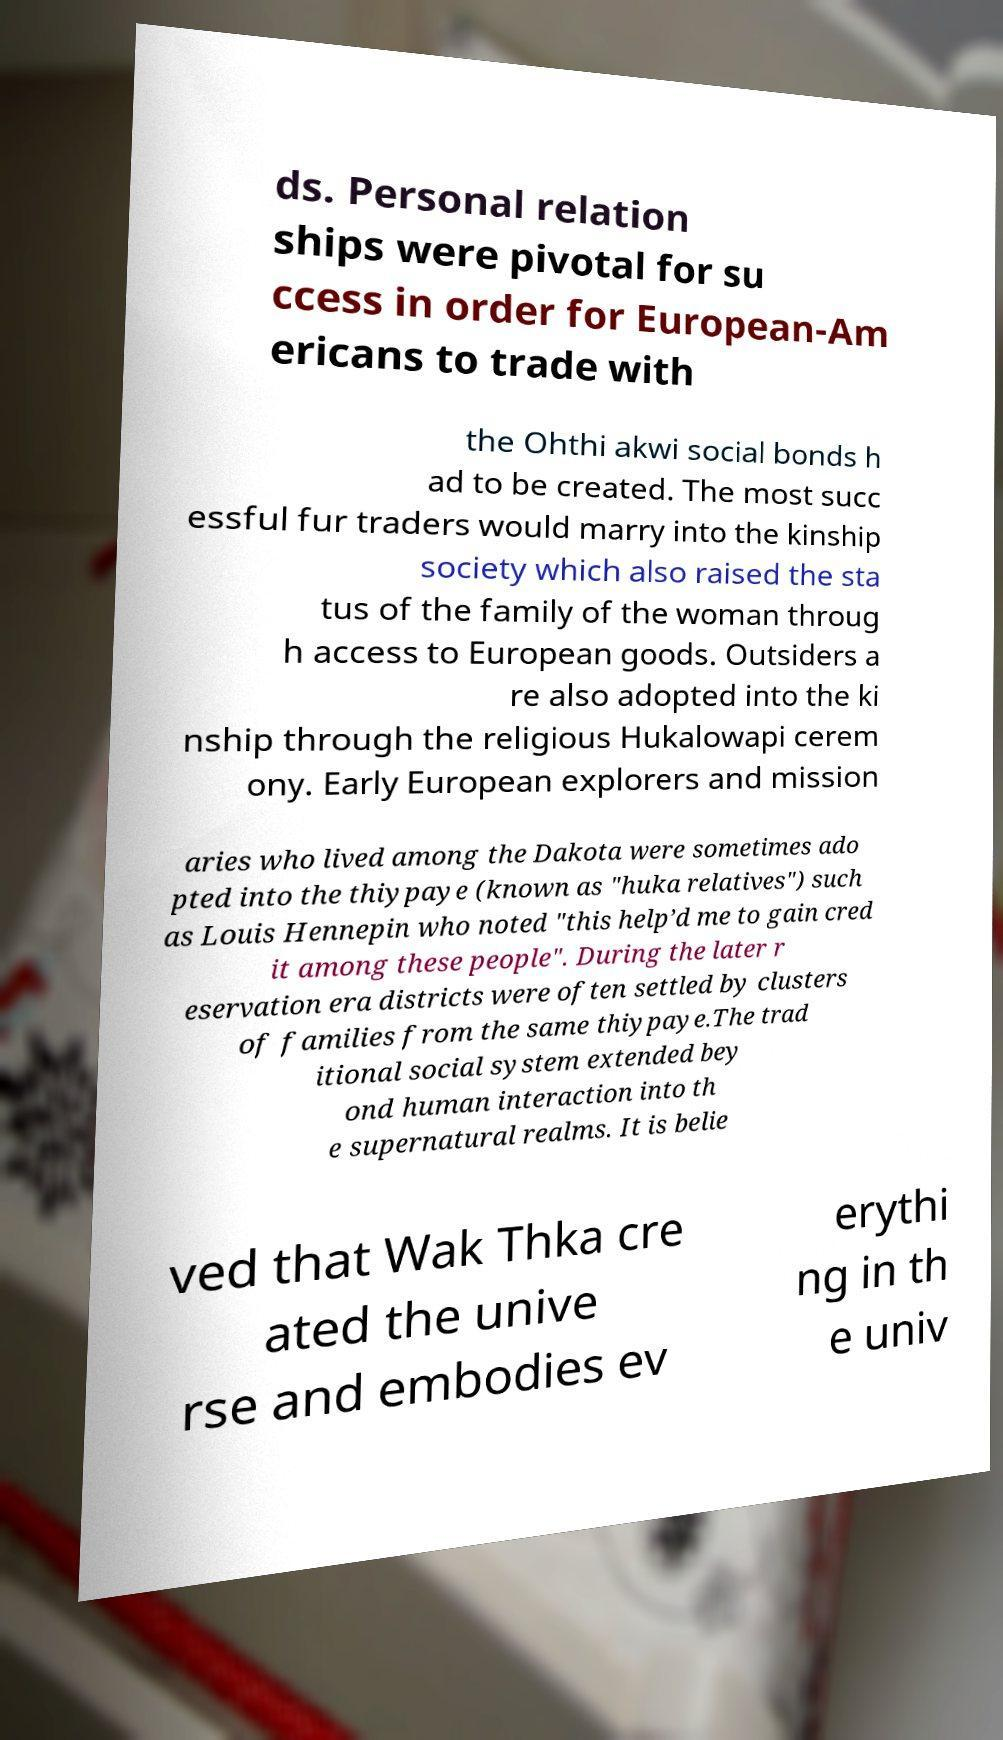Can you read and provide the text displayed in the image?This photo seems to have some interesting text. Can you extract and type it out for me? ds. Personal relation ships were pivotal for su ccess in order for European-Am ericans to trade with the Ohthi akwi social bonds h ad to be created. The most succ essful fur traders would marry into the kinship society which also raised the sta tus of the family of the woman throug h access to European goods. Outsiders a re also adopted into the ki nship through the religious Hukalowapi cerem ony. Early European explorers and mission aries who lived among the Dakota were sometimes ado pted into the thiypaye (known as "huka relatives") such as Louis Hennepin who noted "this help’d me to gain cred it among these people". During the later r eservation era districts were often settled by clusters of families from the same thiypaye.The trad itional social system extended bey ond human interaction into th e supernatural realms. It is belie ved that Wak Thka cre ated the unive rse and embodies ev erythi ng in th e univ 